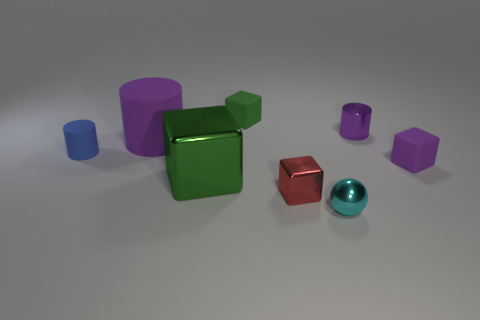Subtract all small green blocks. How many blocks are left? 3 Add 1 tiny cyan matte cylinders. How many objects exist? 9 Subtract all brown cubes. Subtract all cyan balls. How many cubes are left? 4 Subtract all balls. How many objects are left? 7 Subtract all small things. Subtract all small metal cylinders. How many objects are left? 1 Add 2 red metallic objects. How many red metallic objects are left? 3 Add 7 tiny matte things. How many tiny matte things exist? 10 Subtract 0 gray cubes. How many objects are left? 8 